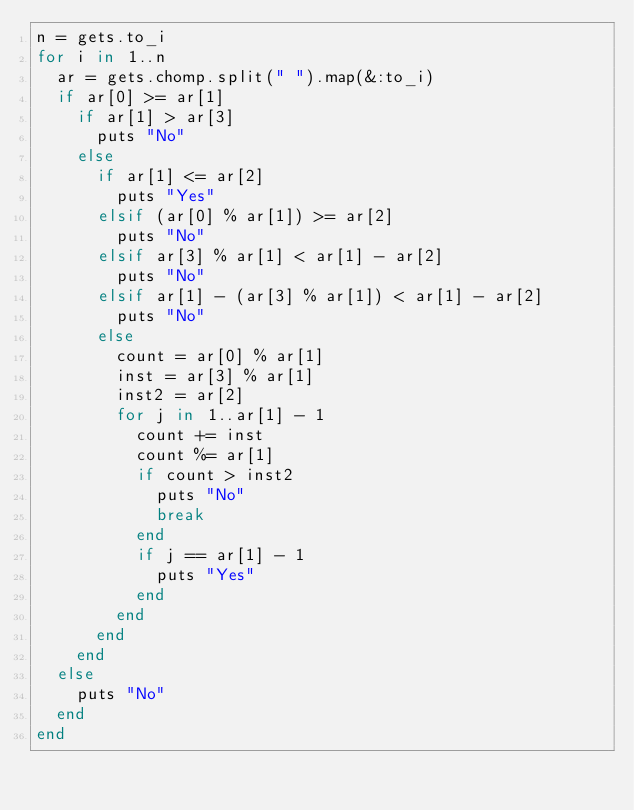Convert code to text. <code><loc_0><loc_0><loc_500><loc_500><_Ruby_>n = gets.to_i
for i in 1..n
  ar = gets.chomp.split(" ").map(&:to_i)
  if ar[0] >= ar[1]
    if ar[1] > ar[3]
      puts "No"
    else
      if ar[1] <= ar[2]
        puts "Yes"
      elsif (ar[0] % ar[1]) >= ar[2]
        puts "No"
      elsif ar[3] % ar[1] < ar[1] - ar[2]
        puts "No"
      elsif ar[1] - (ar[3] % ar[1]) < ar[1] - ar[2]
        puts "No"
      else
        count = ar[0] % ar[1]
        inst = ar[3] % ar[1]
        inst2 = ar[2]
        for j in 1..ar[1] - 1
          count += inst
          count %= ar[1]
          if count > inst2
            puts "No"
            break
          end
          if j == ar[1] - 1
            puts "Yes"
          end
        end
      end
    end
  else
    puts "No"
  end
end</code> 